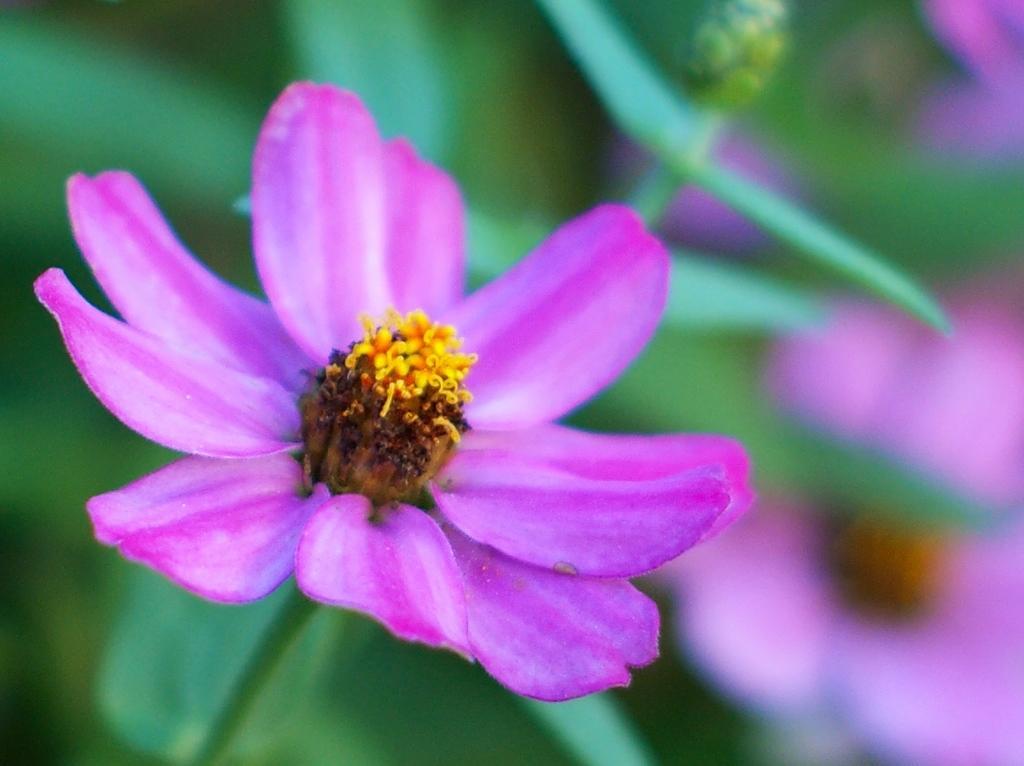Please provide a concise description of this image. In this picture, we can see a flower which is in pink and yellow color. In the background, we can also see leaves which are in green color. 